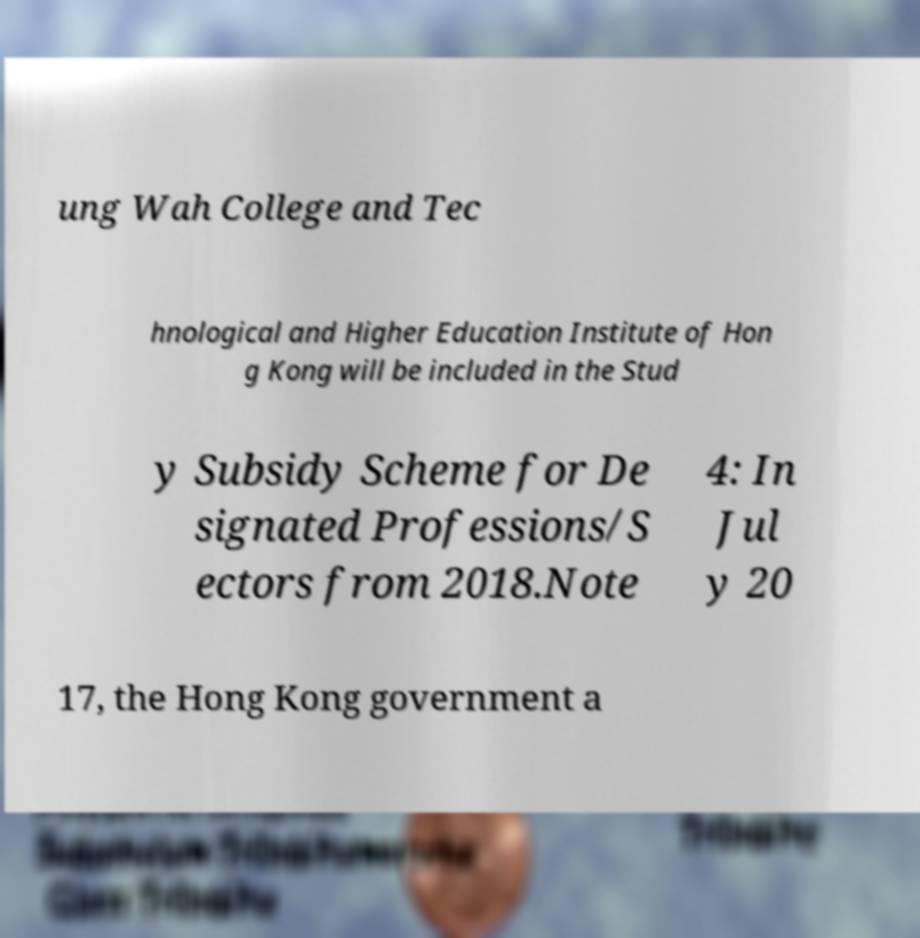Please read and relay the text visible in this image. What does it say? ung Wah College and Tec hnological and Higher Education Institute of Hon g Kong will be included in the Stud y Subsidy Scheme for De signated Professions/S ectors from 2018.Note 4: In Jul y 20 17, the Hong Kong government a 